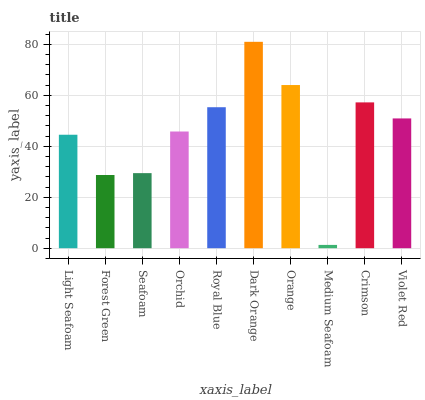Is Medium Seafoam the minimum?
Answer yes or no. Yes. Is Dark Orange the maximum?
Answer yes or no. Yes. Is Forest Green the minimum?
Answer yes or no. No. Is Forest Green the maximum?
Answer yes or no. No. Is Light Seafoam greater than Forest Green?
Answer yes or no. Yes. Is Forest Green less than Light Seafoam?
Answer yes or no. Yes. Is Forest Green greater than Light Seafoam?
Answer yes or no. No. Is Light Seafoam less than Forest Green?
Answer yes or no. No. Is Violet Red the high median?
Answer yes or no. Yes. Is Orchid the low median?
Answer yes or no. Yes. Is Forest Green the high median?
Answer yes or no. No. Is Medium Seafoam the low median?
Answer yes or no. No. 